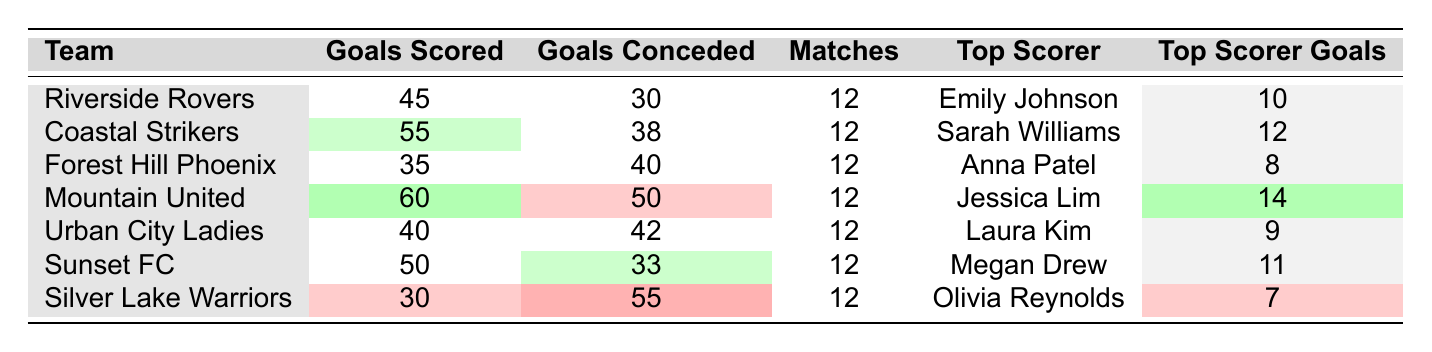What is the highest number of goals scored by a team? By reviewing the "Goals Scored" column in the table, we see that Mountain United has scored the highest with 60 goals.
Answer: 60 Which team has the lowest goals conceded? Looking at the "Goals Conceded" column, Sunset FC has allowed the fewest goals, which is 33.
Answer: 33 Who is the top scorer for Urban City Ladies? In the "Top Scorer" column under Urban City Ladies, it states that Laura Kim is the top scorer.
Answer: Laura Kim What is the goal difference for Coastal Strikers? The goal difference can be calculated by subtracting the "Goals Conceded" from "Goals Scored". For Coastal Strikers, this is 55 - 38 = 17.
Answer: 17 Which team has the highest top scorer goals, and how many goals did they score? Mountain United's top scorer is Jessica Lim, who scored 14 goals, as indicated in their respective columns.
Answer: Jessica Lim, 14 Is it true that Riverside Rovers have scored more goals than they have conceded? To determine this, we compare the "Goals Scored" (45) with "Goals Conceded" (30) for Riverside Rovers. Since 45 is greater than 30, the statement is true.
Answer: Yes What is the average number of goals scored by all teams? To find the average, add the goals scored by all teams (45 + 55 + 35 + 60 + 40 + 50 + 30 = 315) and divide by the number of teams (7). Thus, 315 / 7 = 45.
Answer: 45 Which teams scored more than 50 goals? By checking the "Goals Scored" column, we see that Coastal Strikers (55) and Mountain United (60) are the teams that scored more than 50 goals.
Answer: Coastal Strikers, Mountain United What is the total number of matches played across all teams? Since each team has played 12 matches and there are 7 teams, we multiply 12 by 7 to get a total of 84 matches played.
Answer: 84 How many teams have a top scorer with 10 or more goals? By reviewing the "Top Scorer Goals" column, we find that Coastal Strikers (12), Mountain United (14), and Sunset FC (11) have top scorers with 10 or more goals. That's three teams.
Answer: 3 